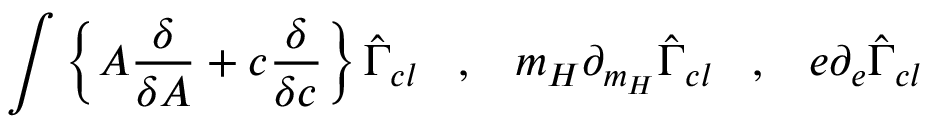Convert formula to latex. <formula><loc_0><loc_0><loc_500><loc_500>\int \left \{ A \frac { \delta } { \delta A } + c \frac { \delta } { \delta c } \right \} \hat { \Gamma } _ { c l } \, , \, m _ { H } \partial _ { m _ { H } } \hat { \Gamma } _ { c l } \, , \, e \partial _ { e } \hat { \Gamma } _ { c l }</formula> 